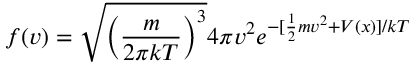Convert formula to latex. <formula><loc_0><loc_0><loc_500><loc_500>f ( v ) = \sqrt { \left ( \frac { m } { 2 \pi k T } \right ) ^ { 3 } } 4 \pi v ^ { 2 } e ^ { - [ \frac { 1 } { 2 } m v ^ { 2 } + V ( x ) ] / { k T } }</formula> 